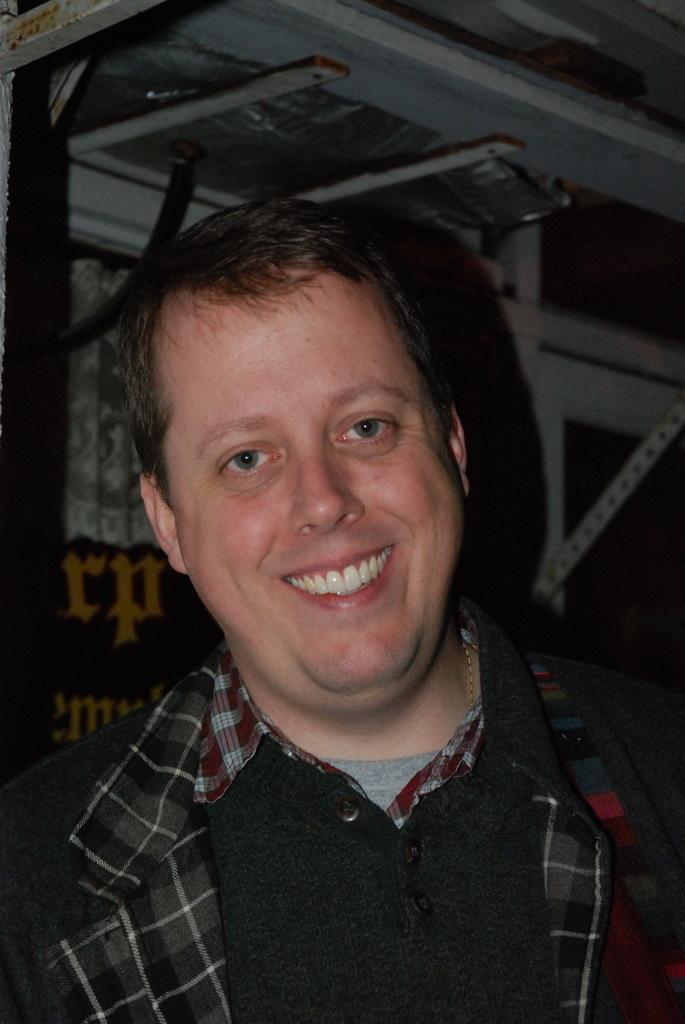Who is present in the image? There is a man in the image. What is the man's facial expression? The man is smiling. What objects can be seen in the image besides the man? There are metal rods in the image. How are the metal rods positioned in the image? The metal rods are connected to a wall. What type of meeting is taking place in the image? There is no meeting present in the image; it only features a man and metal rods connected to a wall. Are the metal rods hot to the touch in the image? The facts provided do not mention the temperature of the metal rods, so it cannot be determined if they are hot or not. 